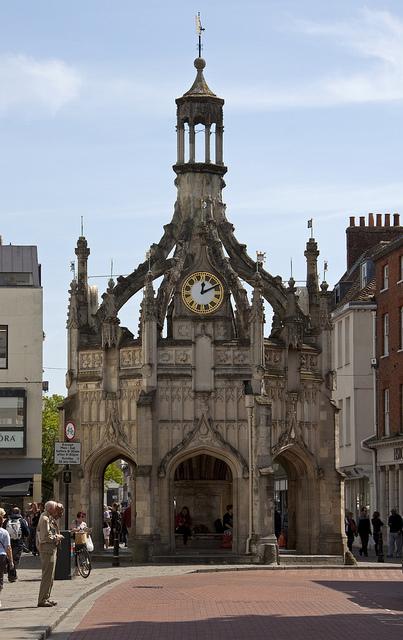Is this a public building?
Quick response, please. Yes. Are there any people visible here?
Keep it brief. Yes. What time does the clock show?
Write a very short answer. 12:10. Is there a clock?
Quick response, please. Yes. Is it snowing here?
Give a very brief answer. No. How many people are in the photo?
Keep it brief. 7. What color is the sky?
Short answer required. Blue. Is the day sunny?
Give a very brief answer. Yes. 